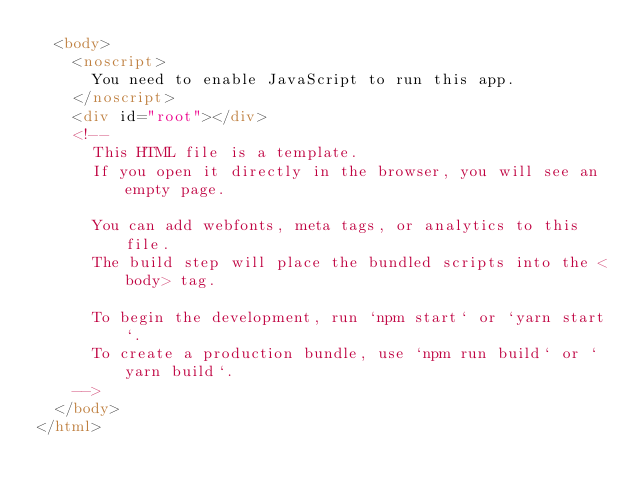Convert code to text. <code><loc_0><loc_0><loc_500><loc_500><_HTML_>  <body>
    <noscript>
      You need to enable JavaScript to run this app.
    </noscript>
    <div id="root"></div>
    <!--
      This HTML file is a template.
      If you open it directly in the browser, you will see an empty page.

      You can add webfonts, meta tags, or analytics to this file.
      The build step will place the bundled scripts into the <body> tag.

      To begin the development, run `npm start` or `yarn start`.
      To create a production bundle, use `npm run build` or `yarn build`.
    -->
  </body>
</html>
</code> 